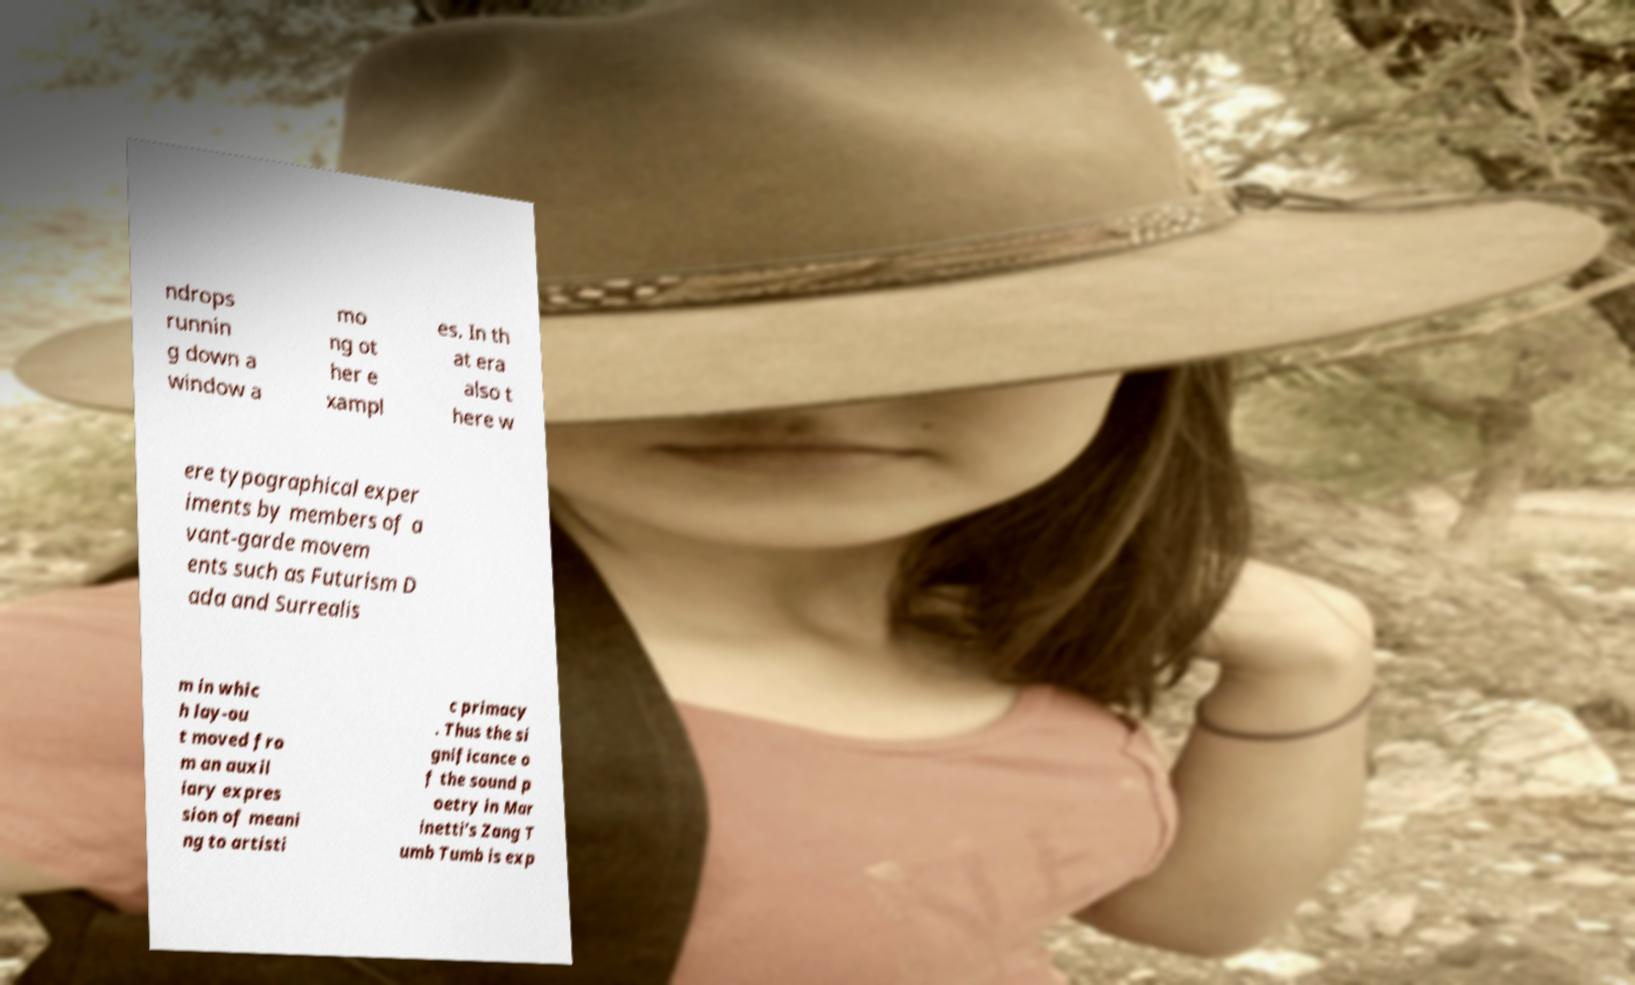Please read and relay the text visible in this image. What does it say? ndrops runnin g down a window a mo ng ot her e xampl es. In th at era also t here w ere typographical exper iments by members of a vant-garde movem ents such as Futurism D ada and Surrealis m in whic h lay-ou t moved fro m an auxil iary expres sion of meani ng to artisti c primacy . Thus the si gnificance o f the sound p oetry in Mar inetti’s Zang T umb Tumb is exp 